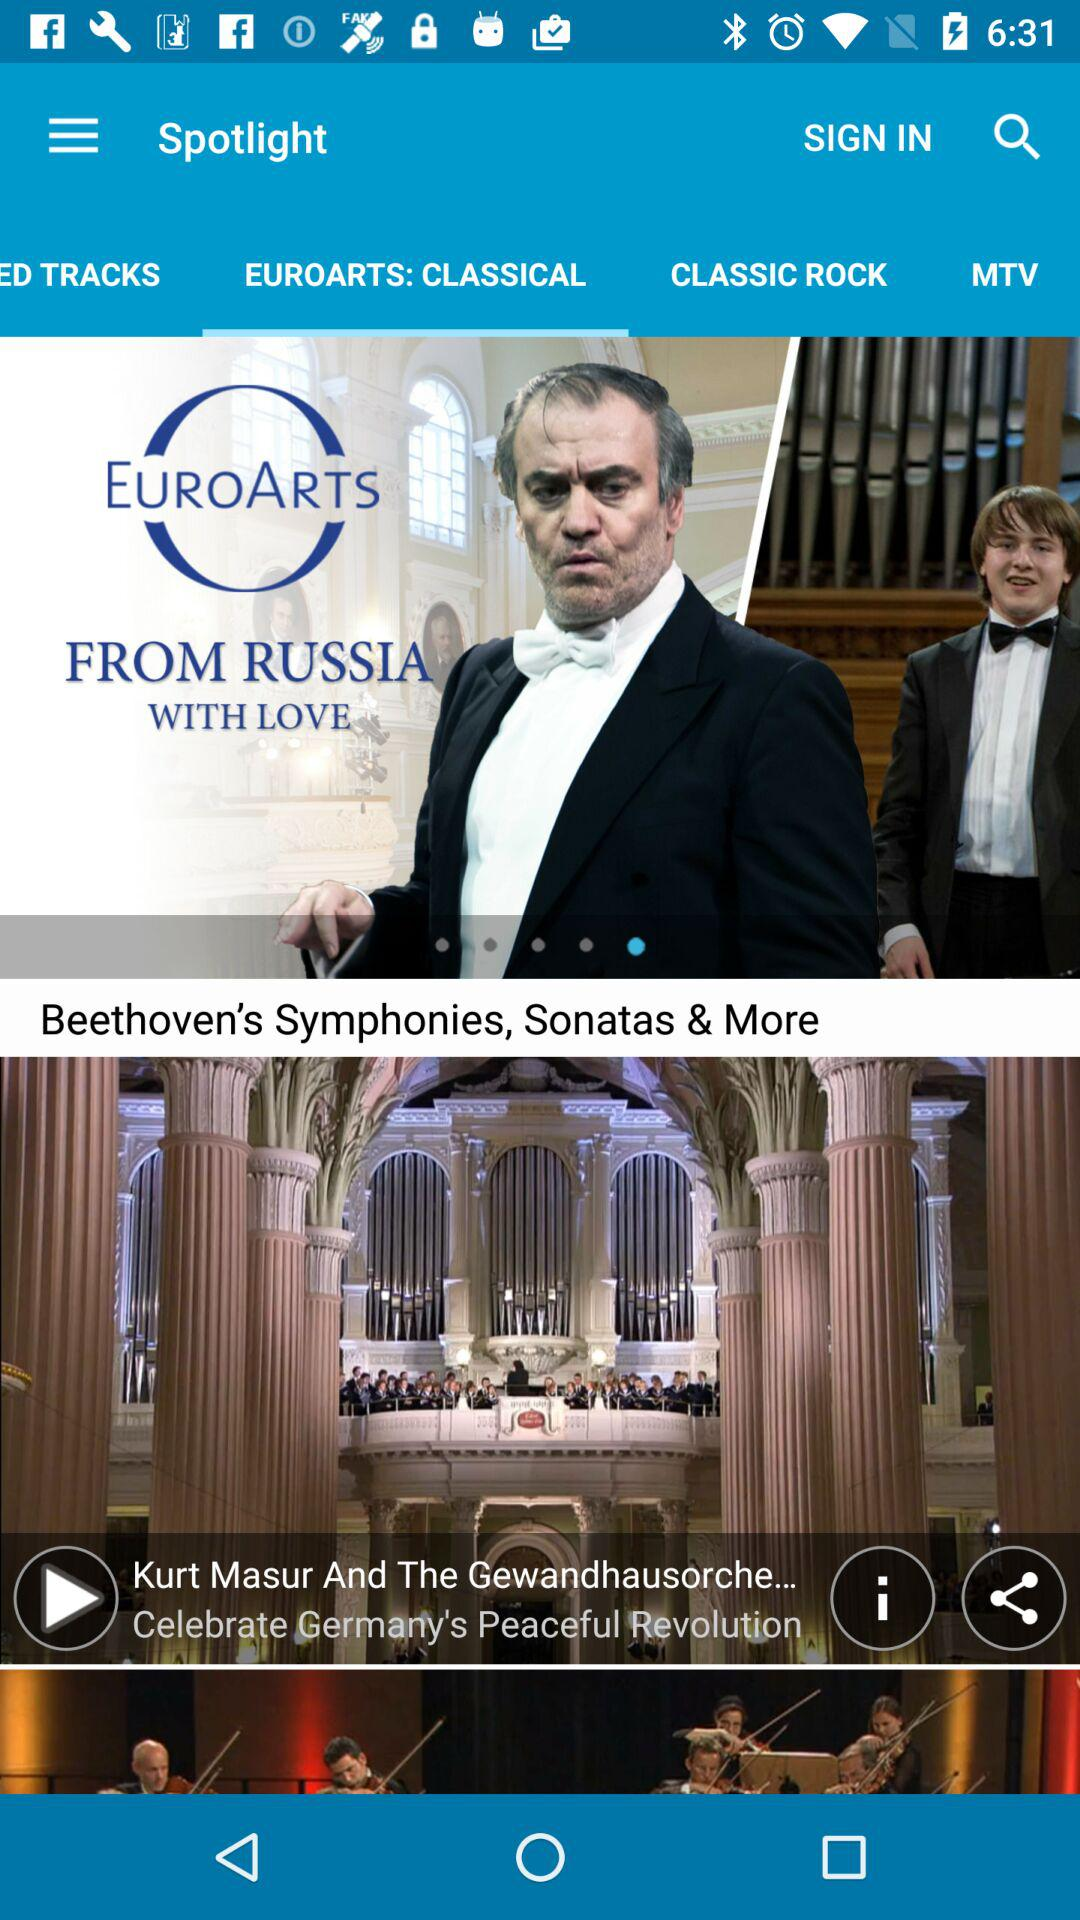What is the selected tab? The selected tab is "EUROARTS: CLASSICAL". 